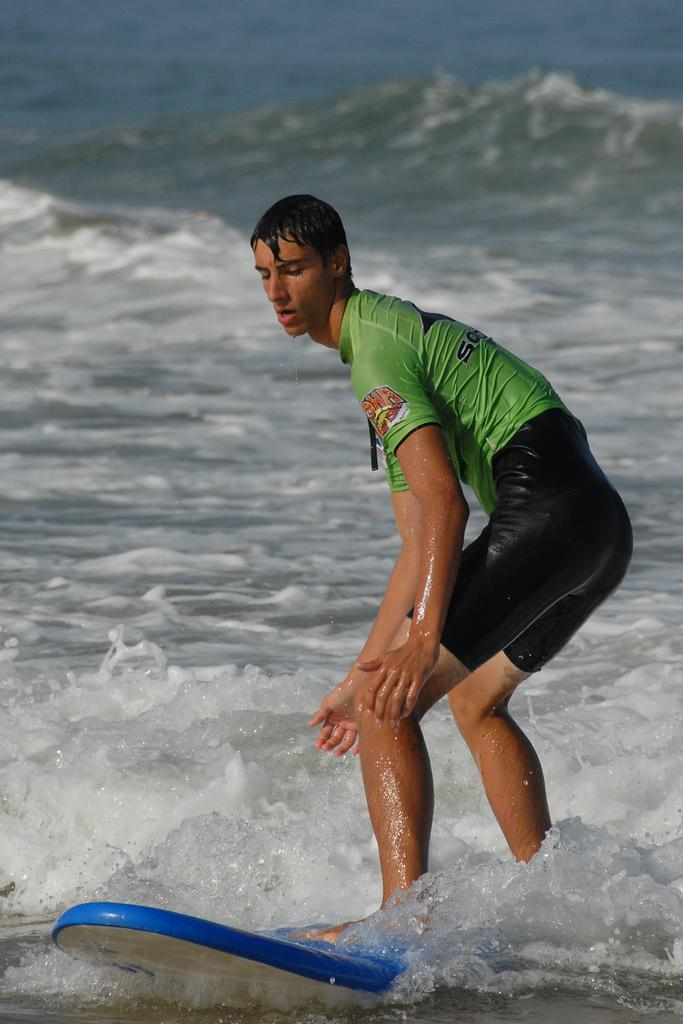What is the main subject of the image? There is a man in the image. What is the man doing in the image? The man is surfing on the water. What does the man desire to do while surfing in the image? The image does not provide information about the man's desires or intentions while surfing. 